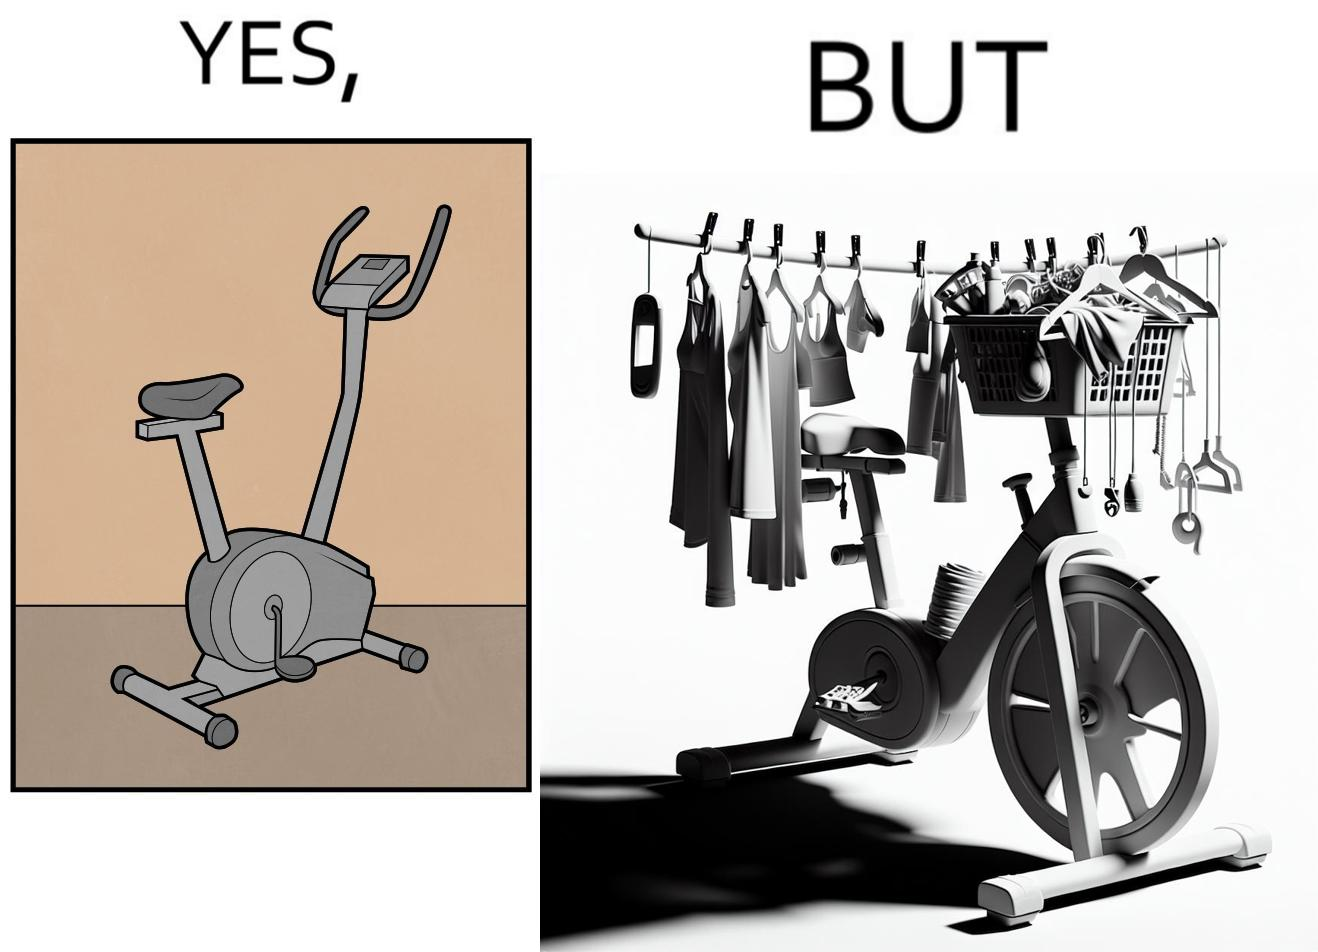Compare the left and right sides of this image. In the left part of the image: An exercise bike In the right part of the image: An exercise bike being used to hang clothes and other items 